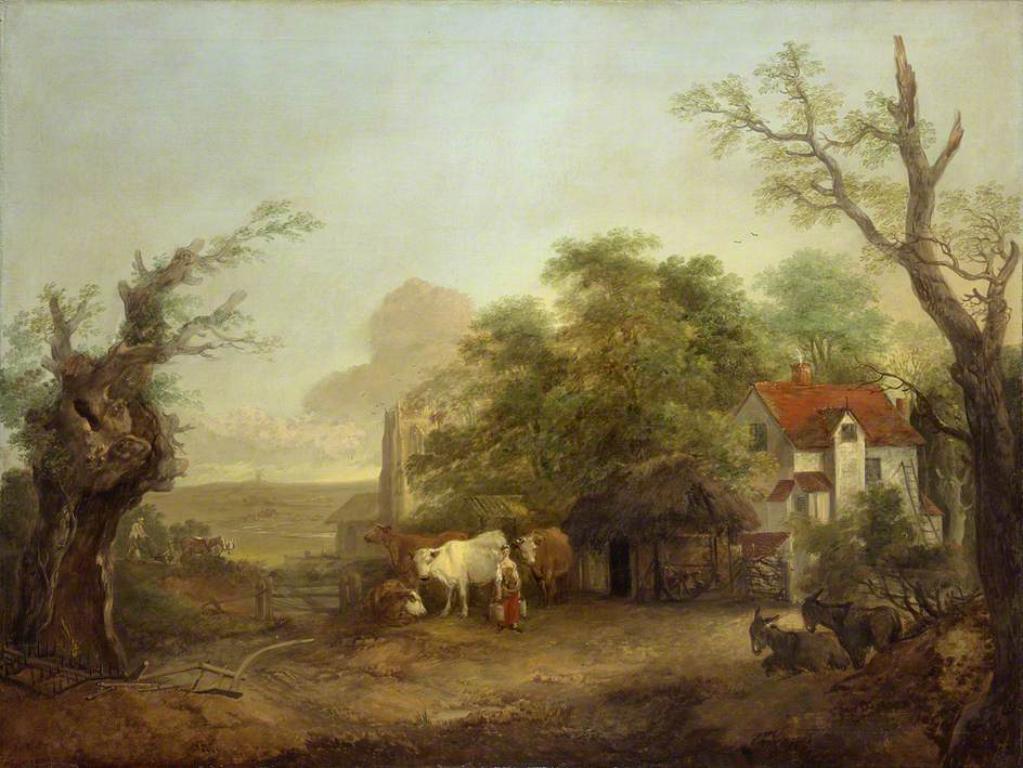How would you summarize this image in a sentence or two? This is a painting. The painting consists of buildings, trees, cattle, person. 